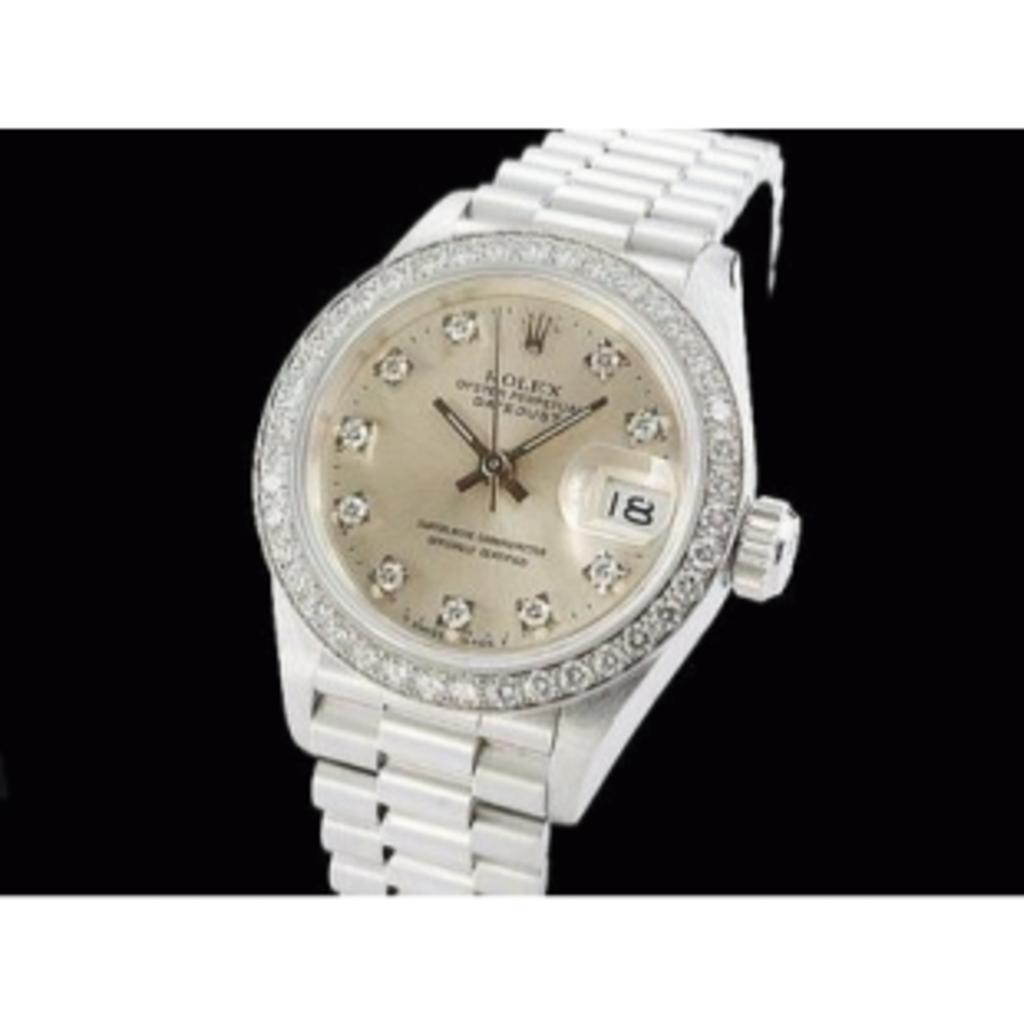What brand is this watch?
Make the answer very short. Rolex. Whats is the date according to the watch?
Make the answer very short. 18. 